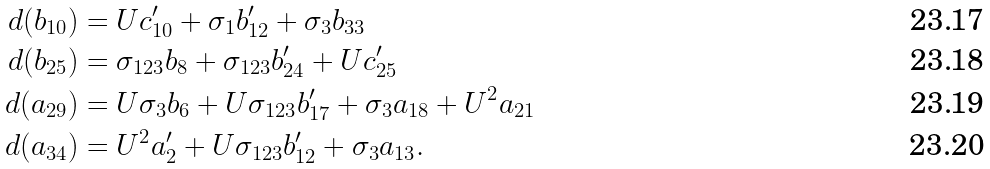<formula> <loc_0><loc_0><loc_500><loc_500>d ( b _ { 1 0 } ) & = U c _ { 1 0 } ^ { \prime } + \sigma _ { 1 } b _ { 1 2 } ^ { \prime } + \sigma _ { 3 } b _ { 3 3 } \\ d ( b _ { 2 5 } ) & = \sigma _ { 1 2 3 } b _ { 8 } + \sigma _ { 1 2 3 } b _ { 2 4 } ^ { \prime } + U c _ { 2 5 } ^ { \prime } \\ d ( a _ { 2 9 } ) & = U \sigma _ { 3 } b _ { 6 } + U \sigma _ { 1 2 3 } b _ { 1 7 } ^ { \prime } + \sigma _ { 3 } a _ { 1 8 } + U ^ { 2 } a _ { 2 1 } \\ d ( a _ { 3 4 } ) & = U ^ { 2 } a _ { 2 } ^ { \prime } + U \sigma _ { 1 2 3 } b _ { 1 2 } ^ { \prime } + \sigma _ { 3 } a _ { 1 3 } .</formula> 